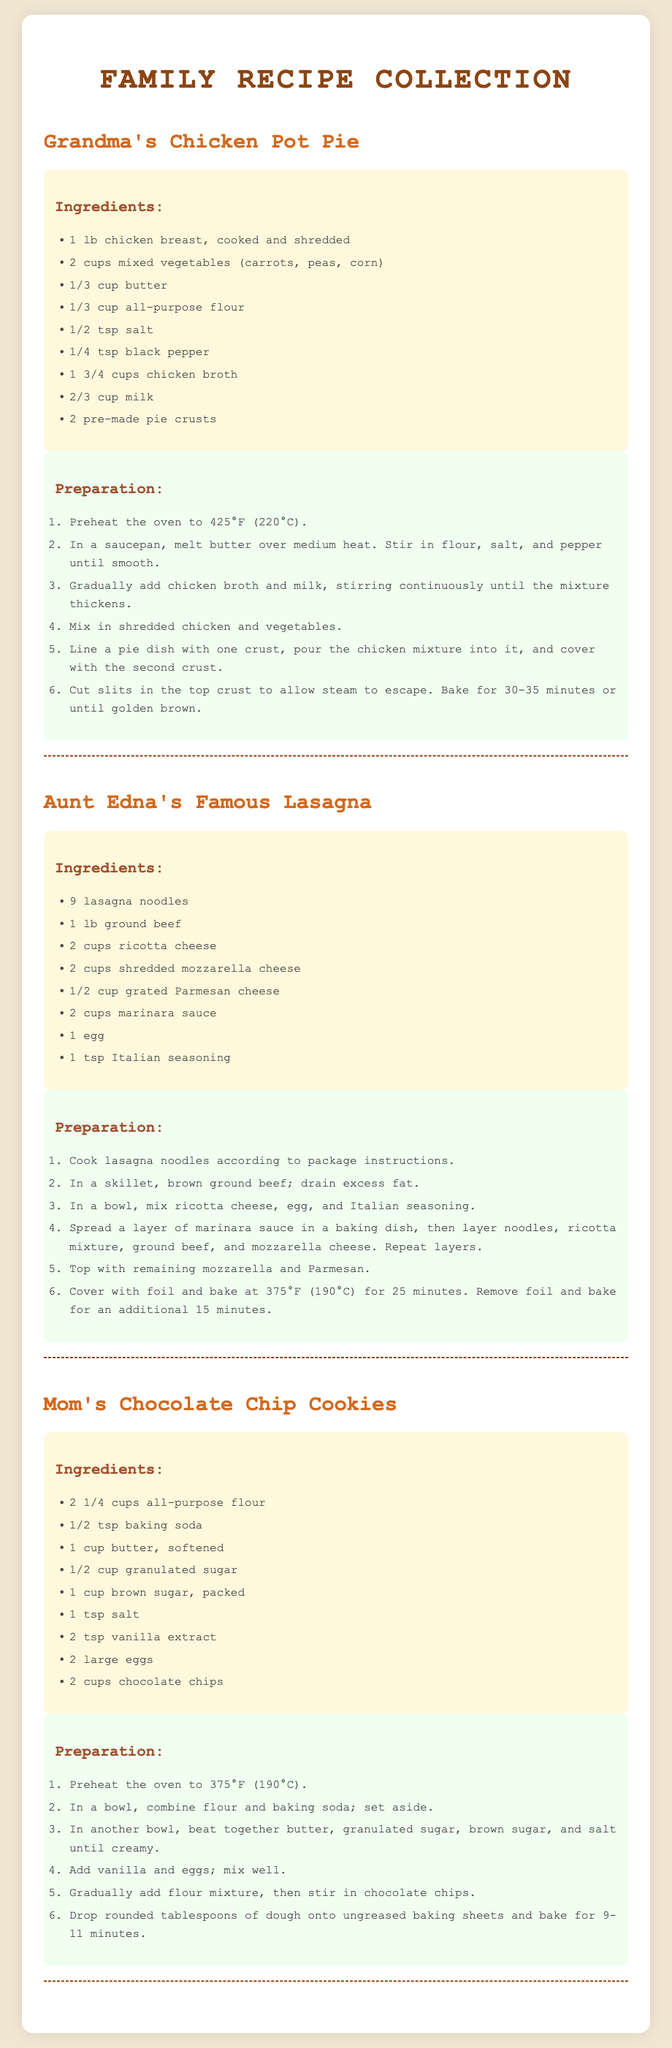What is the title of the document? The title of the document is displayed prominently at the top, indicating its content.
Answer: Family Recipe Collection How many lasagna noodles are needed for Aunt Edna's Famous Lasagna? The recipe specifies the exact amount of lasagna noodles required.
Answer: 9 What is the first step in the preparation of Grandma's Chicken Pot Pie? The preparation instructions outline the first step clearly.
Answer: Preheat the oven to 425°F (220°C) What type of cheese is used in Mom's Chocolate Chip Cookies? The ingredients list mentions the specific types of cheese used in the recipe.
Answer: None How many ingredients are listed for Aunt Edna's Famous Lasagna? The number of ingredients can be counted from the list provided in the recipe.
Answer: 8 What is the main protein in Grandma's Chicken Pot Pie? The dish primarily features a specific type of protein prominently mentioned in the ingredient list.
Answer: Chicken breast What temperature should the oven be set at for baking the cookies? The preparation steps provide information about the correct oven temperature for baking.
Answer: 375°F (190°C) What color is the background of the ingredients section? The document specifies the coloring details relevant to different sections for clarity.
Answer: Light yellow (cream) 